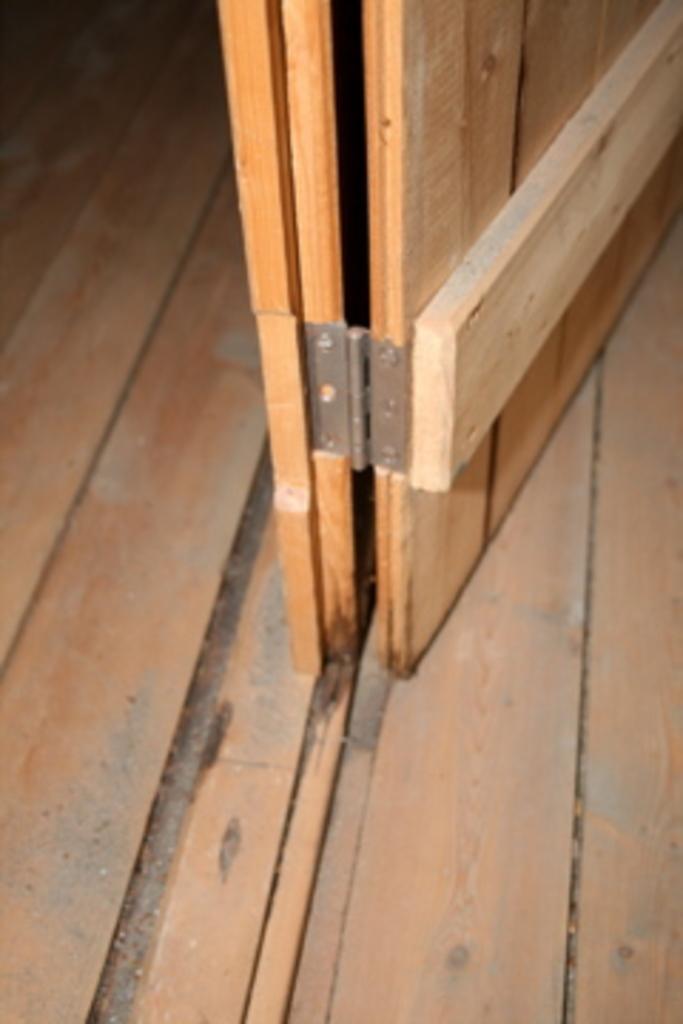In one or two sentences, can you explain what this image depicts? There is a wooden door in wooden floor. The background is dark in color. 